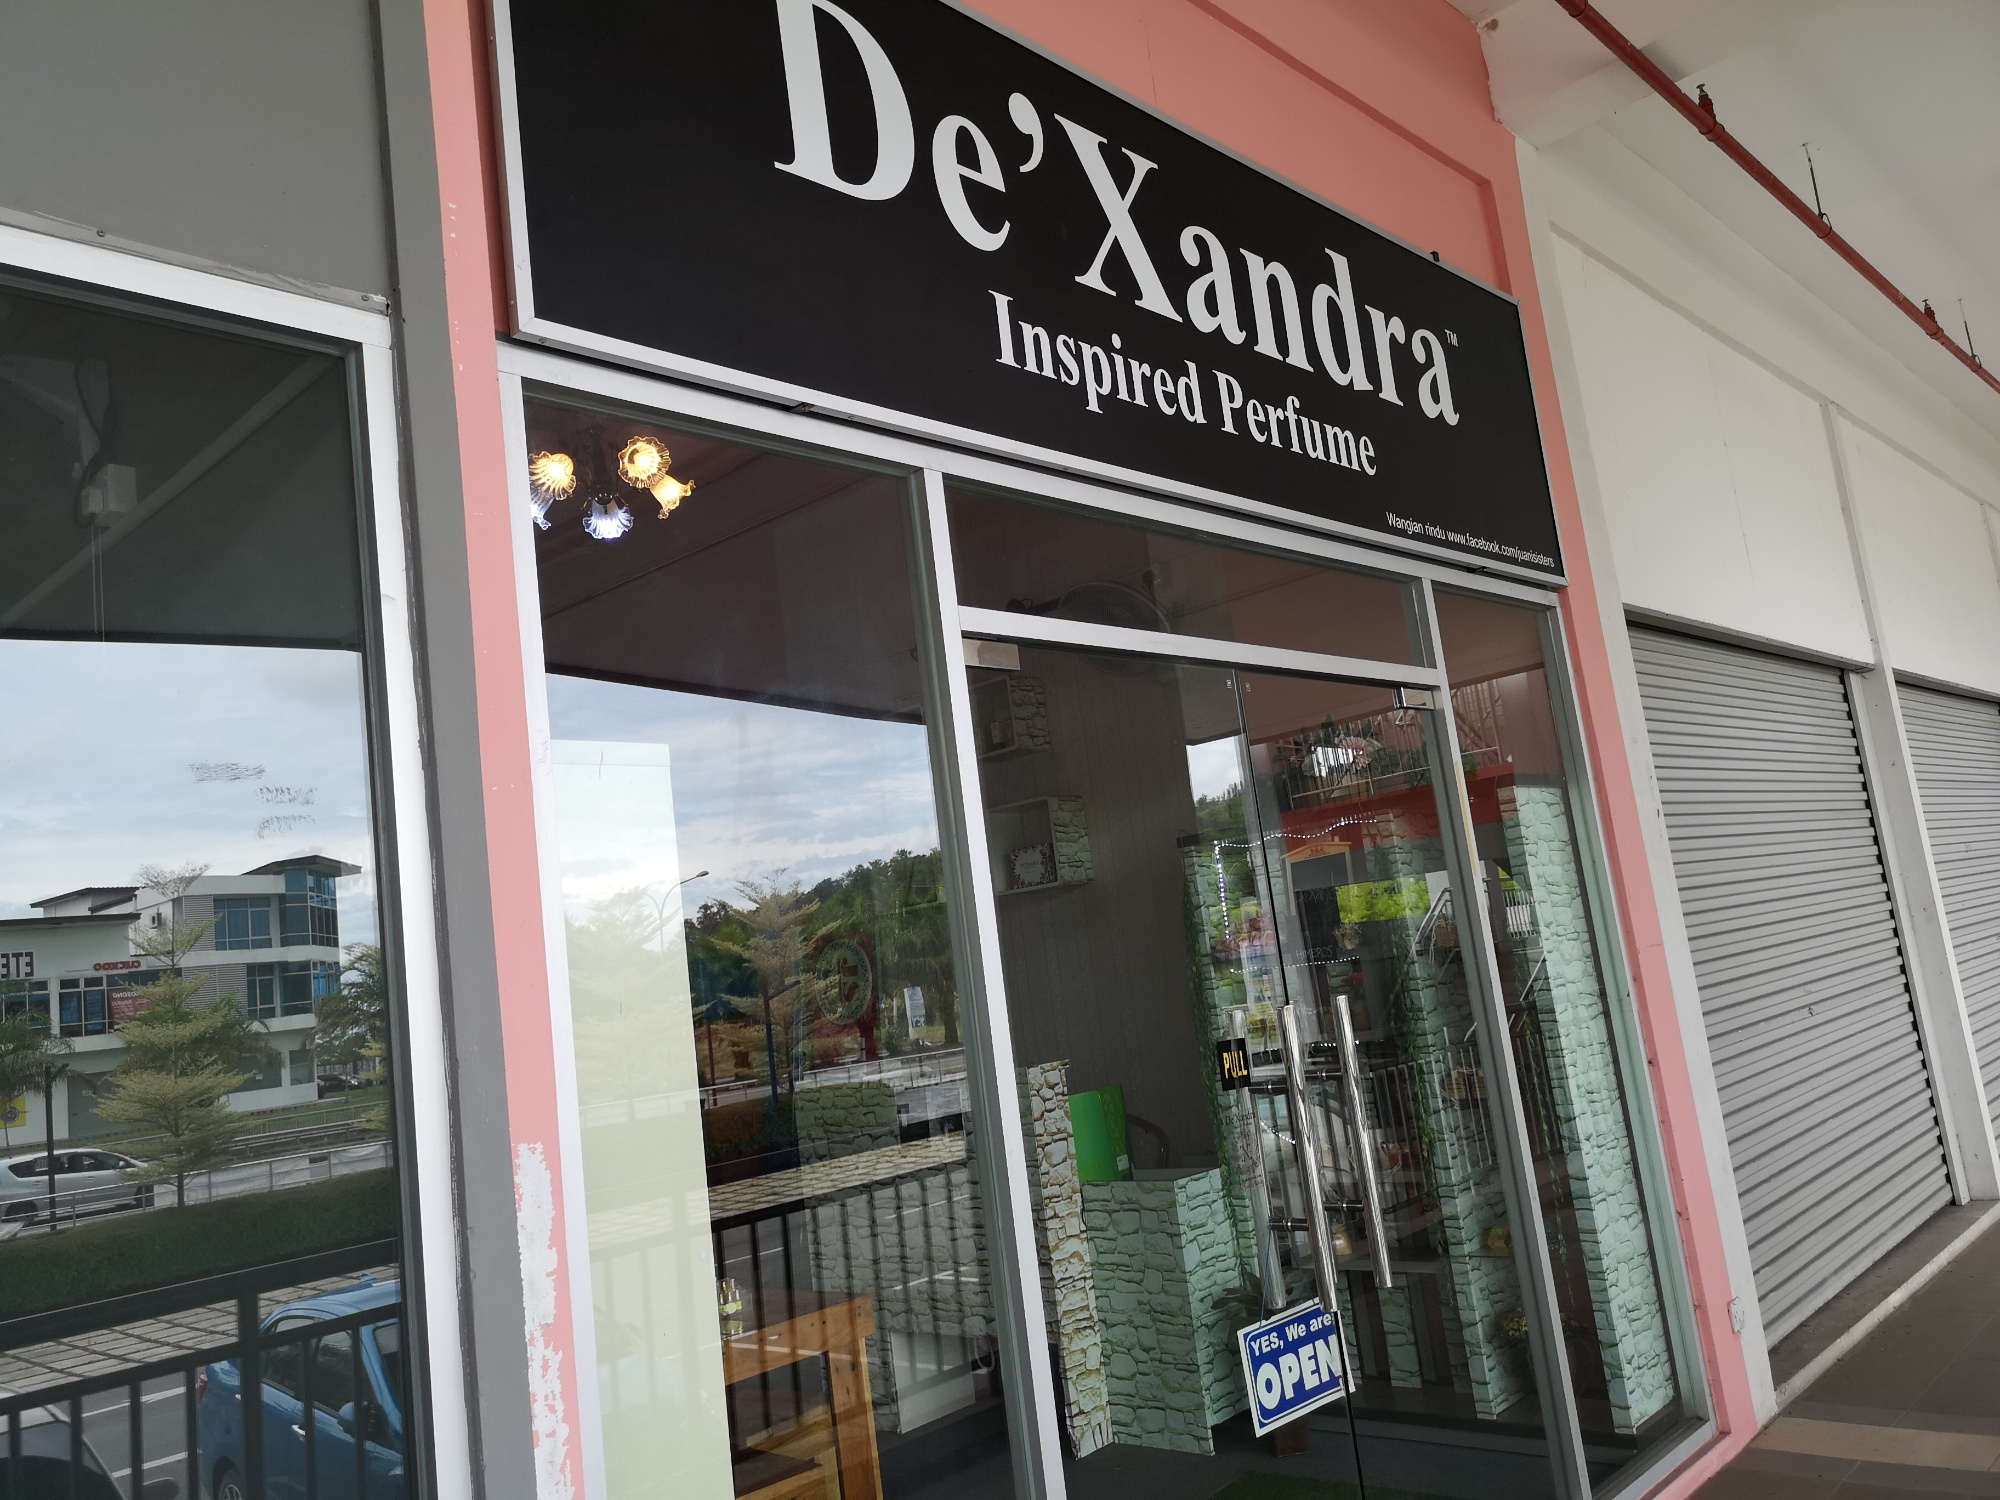What do you see happening in this image? The image captures the storefront of 'De'Xandra Inspired Perfume,' a perfume store distinguished by its prominent black and pink signage. The inviting storefront features a glass window and door, allowing visibility into the interior where an array of perfume bottles is displayed. A blue 'OPEN' sign on the door signals that the store is ready to welcome customers. The store is situated in a strip mall, with an adjacent spacious parking lot and some greenery visible in the surroundings. The overall ambiance suggests a welcoming and serene shopping experience, ideal for those looking to explore a variety of unique fragrances. 